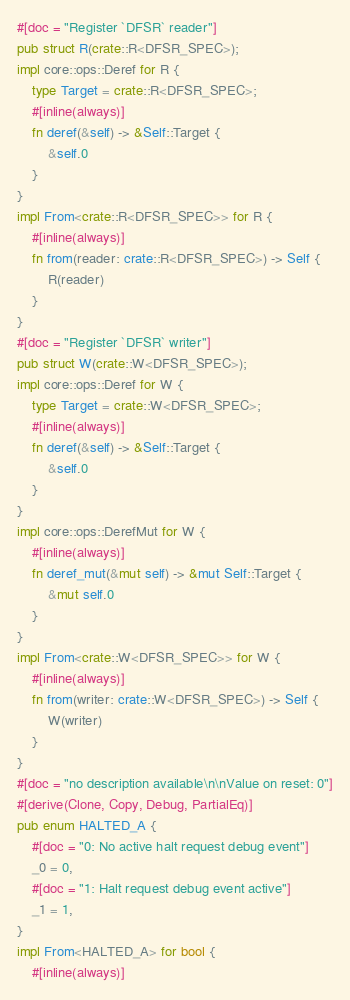<code> <loc_0><loc_0><loc_500><loc_500><_Rust_>#[doc = "Register `DFSR` reader"]
pub struct R(crate::R<DFSR_SPEC>);
impl core::ops::Deref for R {
    type Target = crate::R<DFSR_SPEC>;
    #[inline(always)]
    fn deref(&self) -> &Self::Target {
        &self.0
    }
}
impl From<crate::R<DFSR_SPEC>> for R {
    #[inline(always)]
    fn from(reader: crate::R<DFSR_SPEC>) -> Self {
        R(reader)
    }
}
#[doc = "Register `DFSR` writer"]
pub struct W(crate::W<DFSR_SPEC>);
impl core::ops::Deref for W {
    type Target = crate::W<DFSR_SPEC>;
    #[inline(always)]
    fn deref(&self) -> &Self::Target {
        &self.0
    }
}
impl core::ops::DerefMut for W {
    #[inline(always)]
    fn deref_mut(&mut self) -> &mut Self::Target {
        &mut self.0
    }
}
impl From<crate::W<DFSR_SPEC>> for W {
    #[inline(always)]
    fn from(writer: crate::W<DFSR_SPEC>) -> Self {
        W(writer)
    }
}
#[doc = "no description available\n\nValue on reset: 0"]
#[derive(Clone, Copy, Debug, PartialEq)]
pub enum HALTED_A {
    #[doc = "0: No active halt request debug event"]
    _0 = 0,
    #[doc = "1: Halt request debug event active"]
    _1 = 1,
}
impl From<HALTED_A> for bool {
    #[inline(always)]</code> 